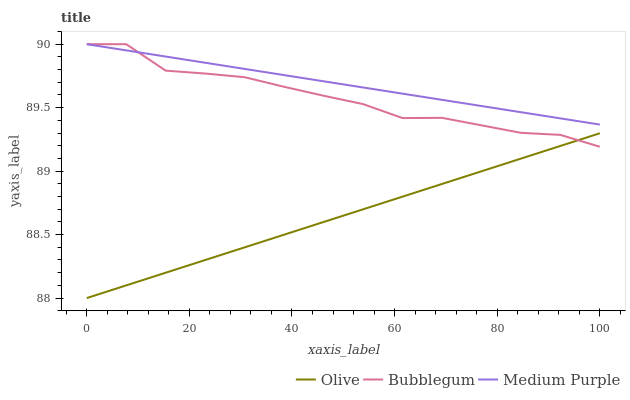Does Bubblegum have the minimum area under the curve?
Answer yes or no. No. Does Bubblegum have the maximum area under the curve?
Answer yes or no. No. Is Bubblegum the smoothest?
Answer yes or no. No. Is Medium Purple the roughest?
Answer yes or no. No. Does Bubblegum have the lowest value?
Answer yes or no. No. Is Olive less than Medium Purple?
Answer yes or no. Yes. Is Medium Purple greater than Olive?
Answer yes or no. Yes. Does Olive intersect Medium Purple?
Answer yes or no. No. 